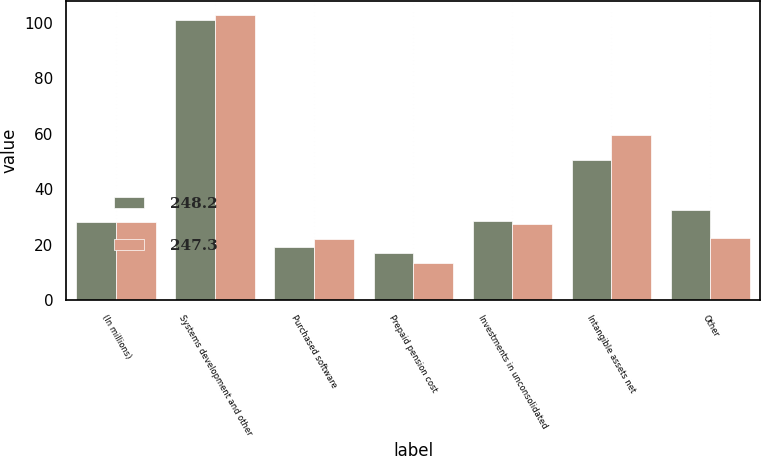Convert chart. <chart><loc_0><loc_0><loc_500><loc_500><stacked_bar_chart><ecel><fcel>(In millions)<fcel>Systems development and other<fcel>Purchased software<fcel>Prepaid pension cost<fcel>Investments in unconsolidated<fcel>Intangible assets net<fcel>Other<nl><fcel>248.2<fcel>27.95<fcel>101<fcel>19<fcel>17<fcel>28.5<fcel>50.3<fcel>32.4<nl><fcel>247.3<fcel>27.95<fcel>102.8<fcel>22.1<fcel>13.3<fcel>27.4<fcel>59.5<fcel>22.2<nl></chart> 